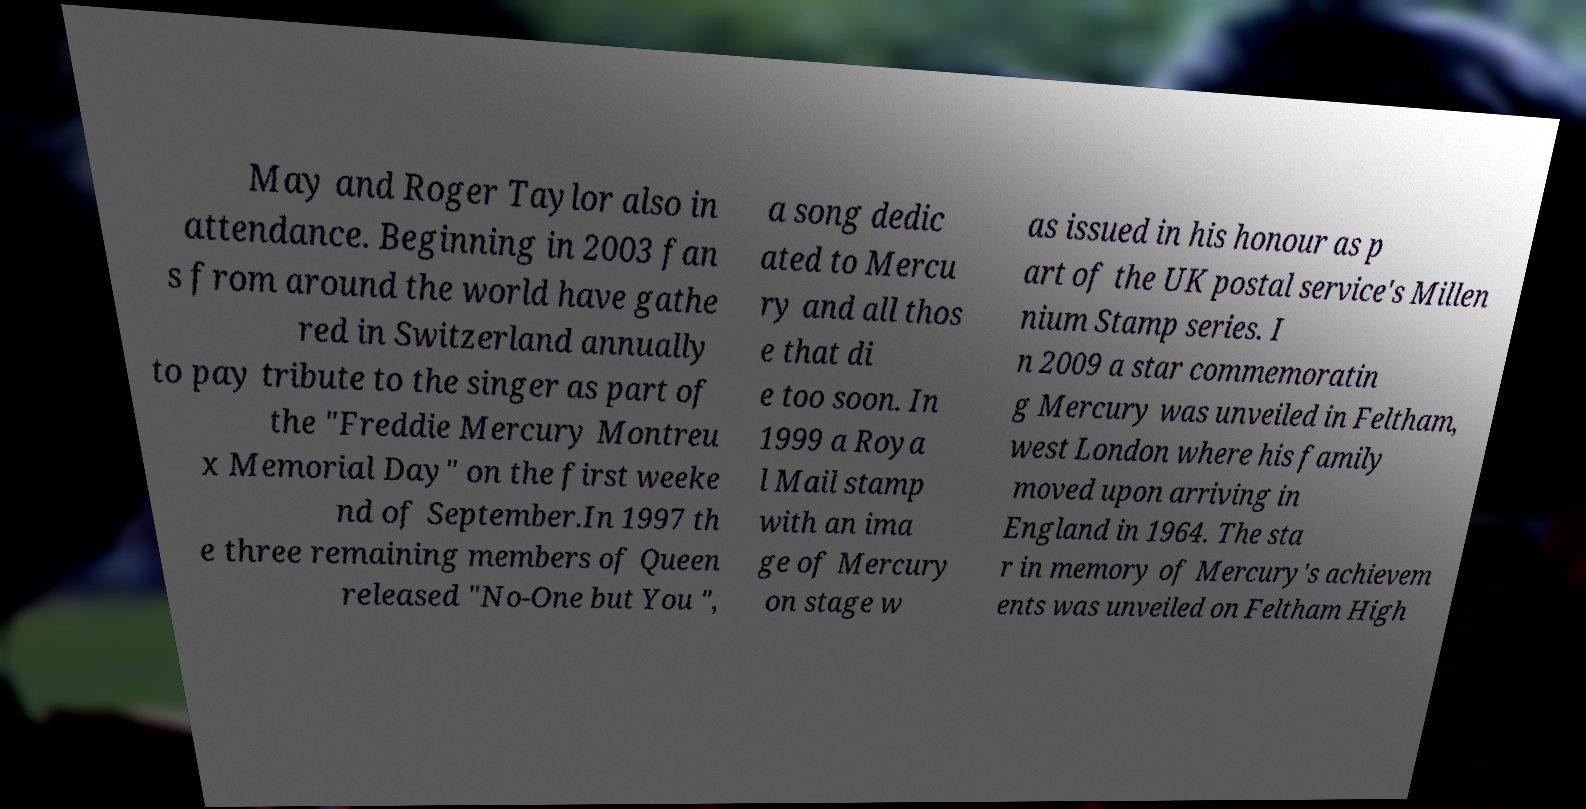Please identify and transcribe the text found in this image. May and Roger Taylor also in attendance. Beginning in 2003 fan s from around the world have gathe red in Switzerland annually to pay tribute to the singer as part of the "Freddie Mercury Montreu x Memorial Day" on the first weeke nd of September.In 1997 th e three remaining members of Queen released "No-One but You ", a song dedic ated to Mercu ry and all thos e that di e too soon. In 1999 a Roya l Mail stamp with an ima ge of Mercury on stage w as issued in his honour as p art of the UK postal service's Millen nium Stamp series. I n 2009 a star commemoratin g Mercury was unveiled in Feltham, west London where his family moved upon arriving in England in 1964. The sta r in memory of Mercury's achievem ents was unveiled on Feltham High 